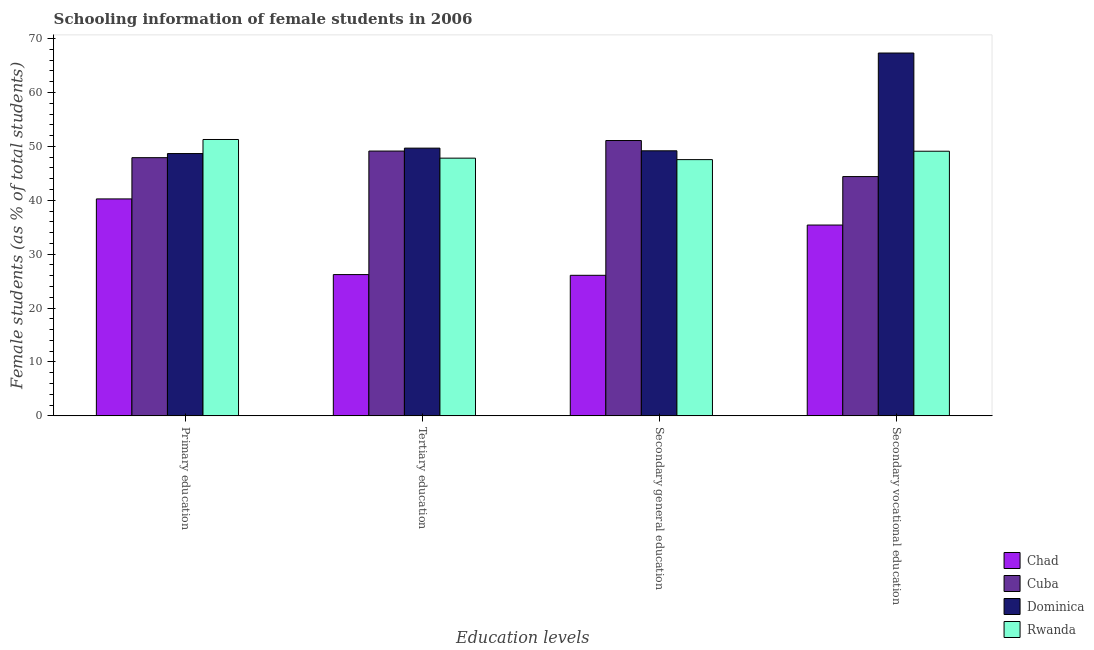How many different coloured bars are there?
Ensure brevity in your answer.  4. How many bars are there on the 3rd tick from the left?
Make the answer very short. 4. What is the label of the 2nd group of bars from the left?
Your response must be concise. Tertiary education. What is the percentage of female students in secondary education in Dominica?
Your response must be concise. 49.17. Across all countries, what is the maximum percentage of female students in secondary vocational education?
Ensure brevity in your answer.  67.32. Across all countries, what is the minimum percentage of female students in secondary vocational education?
Offer a terse response. 35.4. In which country was the percentage of female students in tertiary education maximum?
Your answer should be very brief. Dominica. In which country was the percentage of female students in tertiary education minimum?
Offer a very short reply. Chad. What is the total percentage of female students in secondary education in the graph?
Provide a succinct answer. 173.87. What is the difference between the percentage of female students in secondary vocational education in Dominica and that in Chad?
Provide a short and direct response. 31.91. What is the difference between the percentage of female students in tertiary education in Dominica and the percentage of female students in secondary vocational education in Cuba?
Keep it short and to the point. 5.28. What is the average percentage of female students in secondary vocational education per country?
Make the answer very short. 49.05. What is the difference between the percentage of female students in primary education and percentage of female students in tertiary education in Rwanda?
Make the answer very short. 3.46. In how many countries, is the percentage of female students in primary education greater than 44 %?
Your answer should be compact. 3. What is the ratio of the percentage of female students in secondary vocational education in Chad to that in Rwanda?
Make the answer very short. 0.72. What is the difference between the highest and the second highest percentage of female students in secondary education?
Offer a terse response. 1.91. What is the difference between the highest and the lowest percentage of female students in tertiary education?
Offer a very short reply. 23.46. In how many countries, is the percentage of female students in tertiary education greater than the average percentage of female students in tertiary education taken over all countries?
Ensure brevity in your answer.  3. Is the sum of the percentage of female students in tertiary education in Dominica and Cuba greater than the maximum percentage of female students in secondary education across all countries?
Your response must be concise. Yes. Is it the case that in every country, the sum of the percentage of female students in secondary education and percentage of female students in tertiary education is greater than the sum of percentage of female students in primary education and percentage of female students in secondary vocational education?
Give a very brief answer. No. What does the 3rd bar from the left in Secondary general education represents?
Your answer should be compact. Dominica. What does the 2nd bar from the right in Tertiary education represents?
Provide a succinct answer. Dominica. Is it the case that in every country, the sum of the percentage of female students in primary education and percentage of female students in tertiary education is greater than the percentage of female students in secondary education?
Give a very brief answer. Yes. Are the values on the major ticks of Y-axis written in scientific E-notation?
Your response must be concise. No. Where does the legend appear in the graph?
Provide a succinct answer. Bottom right. How are the legend labels stacked?
Offer a very short reply. Vertical. What is the title of the graph?
Offer a terse response. Schooling information of female students in 2006. What is the label or title of the X-axis?
Make the answer very short. Education levels. What is the label or title of the Y-axis?
Your answer should be very brief. Female students (as % of total students). What is the Female students (as % of total students) in Chad in Primary education?
Ensure brevity in your answer.  40.25. What is the Female students (as % of total students) of Cuba in Primary education?
Keep it short and to the point. 47.9. What is the Female students (as % of total students) of Dominica in Primary education?
Offer a terse response. 48.66. What is the Female students (as % of total students) in Rwanda in Primary education?
Keep it short and to the point. 51.27. What is the Female students (as % of total students) in Chad in Tertiary education?
Provide a succinct answer. 26.21. What is the Female students (as % of total students) in Cuba in Tertiary education?
Provide a short and direct response. 49.13. What is the Female students (as % of total students) in Dominica in Tertiary education?
Give a very brief answer. 49.67. What is the Female students (as % of total students) in Rwanda in Tertiary education?
Your response must be concise. 47.81. What is the Female students (as % of total students) in Chad in Secondary general education?
Give a very brief answer. 26.08. What is the Female students (as % of total students) in Cuba in Secondary general education?
Your answer should be compact. 51.08. What is the Female students (as % of total students) in Dominica in Secondary general education?
Provide a short and direct response. 49.17. What is the Female students (as % of total students) of Rwanda in Secondary general education?
Offer a terse response. 47.54. What is the Female students (as % of total students) in Chad in Secondary vocational education?
Provide a short and direct response. 35.4. What is the Female students (as % of total students) in Cuba in Secondary vocational education?
Offer a terse response. 44.39. What is the Female students (as % of total students) of Dominica in Secondary vocational education?
Ensure brevity in your answer.  67.32. What is the Female students (as % of total students) in Rwanda in Secondary vocational education?
Keep it short and to the point. 49.1. Across all Education levels, what is the maximum Female students (as % of total students) of Chad?
Provide a short and direct response. 40.25. Across all Education levels, what is the maximum Female students (as % of total students) of Cuba?
Your response must be concise. 51.08. Across all Education levels, what is the maximum Female students (as % of total students) of Dominica?
Your answer should be compact. 67.32. Across all Education levels, what is the maximum Female students (as % of total students) of Rwanda?
Ensure brevity in your answer.  51.27. Across all Education levels, what is the minimum Female students (as % of total students) of Chad?
Offer a terse response. 26.08. Across all Education levels, what is the minimum Female students (as % of total students) of Cuba?
Your answer should be very brief. 44.39. Across all Education levels, what is the minimum Female students (as % of total students) in Dominica?
Ensure brevity in your answer.  48.66. Across all Education levels, what is the minimum Female students (as % of total students) in Rwanda?
Keep it short and to the point. 47.54. What is the total Female students (as % of total students) of Chad in the graph?
Offer a terse response. 127.94. What is the total Female students (as % of total students) in Cuba in the graph?
Make the answer very short. 192.51. What is the total Female students (as % of total students) of Dominica in the graph?
Your answer should be very brief. 214.83. What is the total Female students (as % of total students) of Rwanda in the graph?
Offer a terse response. 195.72. What is the difference between the Female students (as % of total students) in Chad in Primary education and that in Tertiary education?
Ensure brevity in your answer.  14.04. What is the difference between the Female students (as % of total students) of Cuba in Primary education and that in Tertiary education?
Provide a short and direct response. -1.23. What is the difference between the Female students (as % of total students) in Dominica in Primary education and that in Tertiary education?
Give a very brief answer. -1.01. What is the difference between the Female students (as % of total students) in Rwanda in Primary education and that in Tertiary education?
Your answer should be very brief. 3.46. What is the difference between the Female students (as % of total students) in Chad in Primary education and that in Secondary general education?
Keep it short and to the point. 14.17. What is the difference between the Female students (as % of total students) in Cuba in Primary education and that in Secondary general education?
Make the answer very short. -3.18. What is the difference between the Female students (as % of total students) in Dominica in Primary education and that in Secondary general education?
Make the answer very short. -0.51. What is the difference between the Female students (as % of total students) of Rwanda in Primary education and that in Secondary general education?
Your response must be concise. 3.73. What is the difference between the Female students (as % of total students) of Chad in Primary education and that in Secondary vocational education?
Make the answer very short. 4.85. What is the difference between the Female students (as % of total students) of Cuba in Primary education and that in Secondary vocational education?
Your response must be concise. 3.51. What is the difference between the Female students (as % of total students) in Dominica in Primary education and that in Secondary vocational education?
Your answer should be very brief. -18.65. What is the difference between the Female students (as % of total students) of Rwanda in Primary education and that in Secondary vocational education?
Make the answer very short. 2.18. What is the difference between the Female students (as % of total students) of Chad in Tertiary education and that in Secondary general education?
Offer a very short reply. 0.13. What is the difference between the Female students (as % of total students) of Cuba in Tertiary education and that in Secondary general education?
Ensure brevity in your answer.  -1.95. What is the difference between the Female students (as % of total students) in Dominica in Tertiary education and that in Secondary general education?
Make the answer very short. 0.5. What is the difference between the Female students (as % of total students) in Rwanda in Tertiary education and that in Secondary general education?
Your response must be concise. 0.27. What is the difference between the Female students (as % of total students) in Chad in Tertiary education and that in Secondary vocational education?
Ensure brevity in your answer.  -9.19. What is the difference between the Female students (as % of total students) of Cuba in Tertiary education and that in Secondary vocational education?
Your answer should be compact. 4.74. What is the difference between the Female students (as % of total students) of Dominica in Tertiary education and that in Secondary vocational education?
Your answer should be very brief. -17.64. What is the difference between the Female students (as % of total students) of Rwanda in Tertiary education and that in Secondary vocational education?
Your answer should be compact. -1.28. What is the difference between the Female students (as % of total students) of Chad in Secondary general education and that in Secondary vocational education?
Provide a succinct answer. -9.33. What is the difference between the Female students (as % of total students) of Cuba in Secondary general education and that in Secondary vocational education?
Offer a terse response. 6.69. What is the difference between the Female students (as % of total students) of Dominica in Secondary general education and that in Secondary vocational education?
Make the answer very short. -18.14. What is the difference between the Female students (as % of total students) of Rwanda in Secondary general education and that in Secondary vocational education?
Keep it short and to the point. -1.56. What is the difference between the Female students (as % of total students) of Chad in Primary education and the Female students (as % of total students) of Cuba in Tertiary education?
Your response must be concise. -8.88. What is the difference between the Female students (as % of total students) in Chad in Primary education and the Female students (as % of total students) in Dominica in Tertiary education?
Your answer should be very brief. -9.42. What is the difference between the Female students (as % of total students) in Chad in Primary education and the Female students (as % of total students) in Rwanda in Tertiary education?
Your response must be concise. -7.56. What is the difference between the Female students (as % of total students) of Cuba in Primary education and the Female students (as % of total students) of Dominica in Tertiary education?
Make the answer very short. -1.77. What is the difference between the Female students (as % of total students) of Cuba in Primary education and the Female students (as % of total students) of Rwanda in Tertiary education?
Ensure brevity in your answer.  0.09. What is the difference between the Female students (as % of total students) in Dominica in Primary education and the Female students (as % of total students) in Rwanda in Tertiary education?
Your response must be concise. 0.85. What is the difference between the Female students (as % of total students) in Chad in Primary education and the Female students (as % of total students) in Cuba in Secondary general education?
Provide a short and direct response. -10.83. What is the difference between the Female students (as % of total students) of Chad in Primary education and the Female students (as % of total students) of Dominica in Secondary general education?
Provide a succinct answer. -8.93. What is the difference between the Female students (as % of total students) of Chad in Primary education and the Female students (as % of total students) of Rwanda in Secondary general education?
Your response must be concise. -7.29. What is the difference between the Female students (as % of total students) of Cuba in Primary education and the Female students (as % of total students) of Dominica in Secondary general education?
Keep it short and to the point. -1.27. What is the difference between the Female students (as % of total students) of Cuba in Primary education and the Female students (as % of total students) of Rwanda in Secondary general education?
Offer a very short reply. 0.36. What is the difference between the Female students (as % of total students) of Dominica in Primary education and the Female students (as % of total students) of Rwanda in Secondary general education?
Provide a short and direct response. 1.12. What is the difference between the Female students (as % of total students) of Chad in Primary education and the Female students (as % of total students) of Cuba in Secondary vocational education?
Offer a very short reply. -4.14. What is the difference between the Female students (as % of total students) of Chad in Primary education and the Female students (as % of total students) of Dominica in Secondary vocational education?
Make the answer very short. -27.07. What is the difference between the Female students (as % of total students) in Chad in Primary education and the Female students (as % of total students) in Rwanda in Secondary vocational education?
Provide a short and direct response. -8.85. What is the difference between the Female students (as % of total students) of Cuba in Primary education and the Female students (as % of total students) of Dominica in Secondary vocational education?
Your answer should be very brief. -19.41. What is the difference between the Female students (as % of total students) of Cuba in Primary education and the Female students (as % of total students) of Rwanda in Secondary vocational education?
Provide a short and direct response. -1.19. What is the difference between the Female students (as % of total students) of Dominica in Primary education and the Female students (as % of total students) of Rwanda in Secondary vocational education?
Give a very brief answer. -0.43. What is the difference between the Female students (as % of total students) in Chad in Tertiary education and the Female students (as % of total students) in Cuba in Secondary general education?
Provide a succinct answer. -24.87. What is the difference between the Female students (as % of total students) of Chad in Tertiary education and the Female students (as % of total students) of Dominica in Secondary general education?
Keep it short and to the point. -22.96. What is the difference between the Female students (as % of total students) of Chad in Tertiary education and the Female students (as % of total students) of Rwanda in Secondary general education?
Ensure brevity in your answer.  -21.33. What is the difference between the Female students (as % of total students) in Cuba in Tertiary education and the Female students (as % of total students) in Dominica in Secondary general education?
Provide a short and direct response. -0.04. What is the difference between the Female students (as % of total students) of Cuba in Tertiary education and the Female students (as % of total students) of Rwanda in Secondary general education?
Your answer should be very brief. 1.59. What is the difference between the Female students (as % of total students) in Dominica in Tertiary education and the Female students (as % of total students) in Rwanda in Secondary general education?
Provide a succinct answer. 2.13. What is the difference between the Female students (as % of total students) of Chad in Tertiary education and the Female students (as % of total students) of Cuba in Secondary vocational education?
Give a very brief answer. -18.18. What is the difference between the Female students (as % of total students) of Chad in Tertiary education and the Female students (as % of total students) of Dominica in Secondary vocational education?
Your answer should be compact. -41.11. What is the difference between the Female students (as % of total students) of Chad in Tertiary education and the Female students (as % of total students) of Rwanda in Secondary vocational education?
Offer a very short reply. -22.89. What is the difference between the Female students (as % of total students) of Cuba in Tertiary education and the Female students (as % of total students) of Dominica in Secondary vocational education?
Offer a terse response. -18.19. What is the difference between the Female students (as % of total students) of Cuba in Tertiary education and the Female students (as % of total students) of Rwanda in Secondary vocational education?
Provide a succinct answer. 0.03. What is the difference between the Female students (as % of total students) in Dominica in Tertiary education and the Female students (as % of total students) in Rwanda in Secondary vocational education?
Provide a succinct answer. 0.58. What is the difference between the Female students (as % of total students) of Chad in Secondary general education and the Female students (as % of total students) of Cuba in Secondary vocational education?
Your answer should be compact. -18.32. What is the difference between the Female students (as % of total students) in Chad in Secondary general education and the Female students (as % of total students) in Dominica in Secondary vocational education?
Provide a short and direct response. -41.24. What is the difference between the Female students (as % of total students) in Chad in Secondary general education and the Female students (as % of total students) in Rwanda in Secondary vocational education?
Offer a terse response. -23.02. What is the difference between the Female students (as % of total students) of Cuba in Secondary general education and the Female students (as % of total students) of Dominica in Secondary vocational education?
Make the answer very short. -16.23. What is the difference between the Female students (as % of total students) in Cuba in Secondary general education and the Female students (as % of total students) in Rwanda in Secondary vocational education?
Offer a terse response. 1.99. What is the difference between the Female students (as % of total students) in Dominica in Secondary general education and the Female students (as % of total students) in Rwanda in Secondary vocational education?
Offer a terse response. 0.08. What is the average Female students (as % of total students) of Chad per Education levels?
Provide a succinct answer. 31.98. What is the average Female students (as % of total students) in Cuba per Education levels?
Make the answer very short. 48.13. What is the average Female students (as % of total students) of Dominica per Education levels?
Offer a very short reply. 53.71. What is the average Female students (as % of total students) in Rwanda per Education levels?
Give a very brief answer. 48.93. What is the difference between the Female students (as % of total students) in Chad and Female students (as % of total students) in Cuba in Primary education?
Your answer should be compact. -7.65. What is the difference between the Female students (as % of total students) of Chad and Female students (as % of total students) of Dominica in Primary education?
Give a very brief answer. -8.42. What is the difference between the Female students (as % of total students) of Chad and Female students (as % of total students) of Rwanda in Primary education?
Your answer should be compact. -11.02. What is the difference between the Female students (as % of total students) of Cuba and Female students (as % of total students) of Dominica in Primary education?
Provide a succinct answer. -0.76. What is the difference between the Female students (as % of total students) in Cuba and Female students (as % of total students) in Rwanda in Primary education?
Provide a short and direct response. -3.37. What is the difference between the Female students (as % of total students) in Dominica and Female students (as % of total students) in Rwanda in Primary education?
Ensure brevity in your answer.  -2.61. What is the difference between the Female students (as % of total students) of Chad and Female students (as % of total students) of Cuba in Tertiary education?
Your answer should be very brief. -22.92. What is the difference between the Female students (as % of total students) in Chad and Female students (as % of total students) in Dominica in Tertiary education?
Provide a short and direct response. -23.46. What is the difference between the Female students (as % of total students) of Chad and Female students (as % of total students) of Rwanda in Tertiary education?
Make the answer very short. -21.6. What is the difference between the Female students (as % of total students) in Cuba and Female students (as % of total students) in Dominica in Tertiary education?
Ensure brevity in your answer.  -0.54. What is the difference between the Female students (as % of total students) of Cuba and Female students (as % of total students) of Rwanda in Tertiary education?
Offer a terse response. 1.32. What is the difference between the Female students (as % of total students) of Dominica and Female students (as % of total students) of Rwanda in Tertiary education?
Keep it short and to the point. 1.86. What is the difference between the Female students (as % of total students) in Chad and Female students (as % of total students) in Cuba in Secondary general education?
Keep it short and to the point. -25.01. What is the difference between the Female students (as % of total students) in Chad and Female students (as % of total students) in Dominica in Secondary general education?
Keep it short and to the point. -23.1. What is the difference between the Female students (as % of total students) in Chad and Female students (as % of total students) in Rwanda in Secondary general education?
Offer a terse response. -21.46. What is the difference between the Female students (as % of total students) in Cuba and Female students (as % of total students) in Dominica in Secondary general education?
Offer a terse response. 1.91. What is the difference between the Female students (as % of total students) of Cuba and Female students (as % of total students) of Rwanda in Secondary general education?
Provide a short and direct response. 3.54. What is the difference between the Female students (as % of total students) in Dominica and Female students (as % of total students) in Rwanda in Secondary general education?
Your answer should be very brief. 1.63. What is the difference between the Female students (as % of total students) in Chad and Female students (as % of total students) in Cuba in Secondary vocational education?
Ensure brevity in your answer.  -8.99. What is the difference between the Female students (as % of total students) in Chad and Female students (as % of total students) in Dominica in Secondary vocational education?
Your response must be concise. -31.91. What is the difference between the Female students (as % of total students) in Chad and Female students (as % of total students) in Rwanda in Secondary vocational education?
Provide a short and direct response. -13.69. What is the difference between the Female students (as % of total students) of Cuba and Female students (as % of total students) of Dominica in Secondary vocational education?
Make the answer very short. -22.92. What is the difference between the Female students (as % of total students) of Cuba and Female students (as % of total students) of Rwanda in Secondary vocational education?
Your answer should be very brief. -4.7. What is the difference between the Female students (as % of total students) of Dominica and Female students (as % of total students) of Rwanda in Secondary vocational education?
Provide a succinct answer. 18.22. What is the ratio of the Female students (as % of total students) in Chad in Primary education to that in Tertiary education?
Keep it short and to the point. 1.54. What is the ratio of the Female students (as % of total students) of Dominica in Primary education to that in Tertiary education?
Offer a terse response. 0.98. What is the ratio of the Female students (as % of total students) of Rwanda in Primary education to that in Tertiary education?
Make the answer very short. 1.07. What is the ratio of the Female students (as % of total students) of Chad in Primary education to that in Secondary general education?
Offer a very short reply. 1.54. What is the ratio of the Female students (as % of total students) in Cuba in Primary education to that in Secondary general education?
Offer a terse response. 0.94. What is the ratio of the Female students (as % of total students) of Rwanda in Primary education to that in Secondary general education?
Make the answer very short. 1.08. What is the ratio of the Female students (as % of total students) of Chad in Primary education to that in Secondary vocational education?
Provide a succinct answer. 1.14. What is the ratio of the Female students (as % of total students) in Cuba in Primary education to that in Secondary vocational education?
Keep it short and to the point. 1.08. What is the ratio of the Female students (as % of total students) in Dominica in Primary education to that in Secondary vocational education?
Offer a very short reply. 0.72. What is the ratio of the Female students (as % of total students) of Rwanda in Primary education to that in Secondary vocational education?
Your answer should be compact. 1.04. What is the ratio of the Female students (as % of total students) in Chad in Tertiary education to that in Secondary general education?
Ensure brevity in your answer.  1.01. What is the ratio of the Female students (as % of total students) of Cuba in Tertiary education to that in Secondary general education?
Your answer should be very brief. 0.96. What is the ratio of the Female students (as % of total students) in Chad in Tertiary education to that in Secondary vocational education?
Keep it short and to the point. 0.74. What is the ratio of the Female students (as % of total students) of Cuba in Tertiary education to that in Secondary vocational education?
Ensure brevity in your answer.  1.11. What is the ratio of the Female students (as % of total students) in Dominica in Tertiary education to that in Secondary vocational education?
Keep it short and to the point. 0.74. What is the ratio of the Female students (as % of total students) of Rwanda in Tertiary education to that in Secondary vocational education?
Offer a very short reply. 0.97. What is the ratio of the Female students (as % of total students) of Chad in Secondary general education to that in Secondary vocational education?
Provide a succinct answer. 0.74. What is the ratio of the Female students (as % of total students) of Cuba in Secondary general education to that in Secondary vocational education?
Provide a succinct answer. 1.15. What is the ratio of the Female students (as % of total students) of Dominica in Secondary general education to that in Secondary vocational education?
Keep it short and to the point. 0.73. What is the ratio of the Female students (as % of total students) in Rwanda in Secondary general education to that in Secondary vocational education?
Provide a succinct answer. 0.97. What is the difference between the highest and the second highest Female students (as % of total students) in Chad?
Provide a succinct answer. 4.85. What is the difference between the highest and the second highest Female students (as % of total students) in Cuba?
Your answer should be very brief. 1.95. What is the difference between the highest and the second highest Female students (as % of total students) of Dominica?
Offer a terse response. 17.64. What is the difference between the highest and the second highest Female students (as % of total students) in Rwanda?
Make the answer very short. 2.18. What is the difference between the highest and the lowest Female students (as % of total students) of Chad?
Offer a terse response. 14.17. What is the difference between the highest and the lowest Female students (as % of total students) of Cuba?
Ensure brevity in your answer.  6.69. What is the difference between the highest and the lowest Female students (as % of total students) in Dominica?
Give a very brief answer. 18.65. What is the difference between the highest and the lowest Female students (as % of total students) of Rwanda?
Your response must be concise. 3.73. 